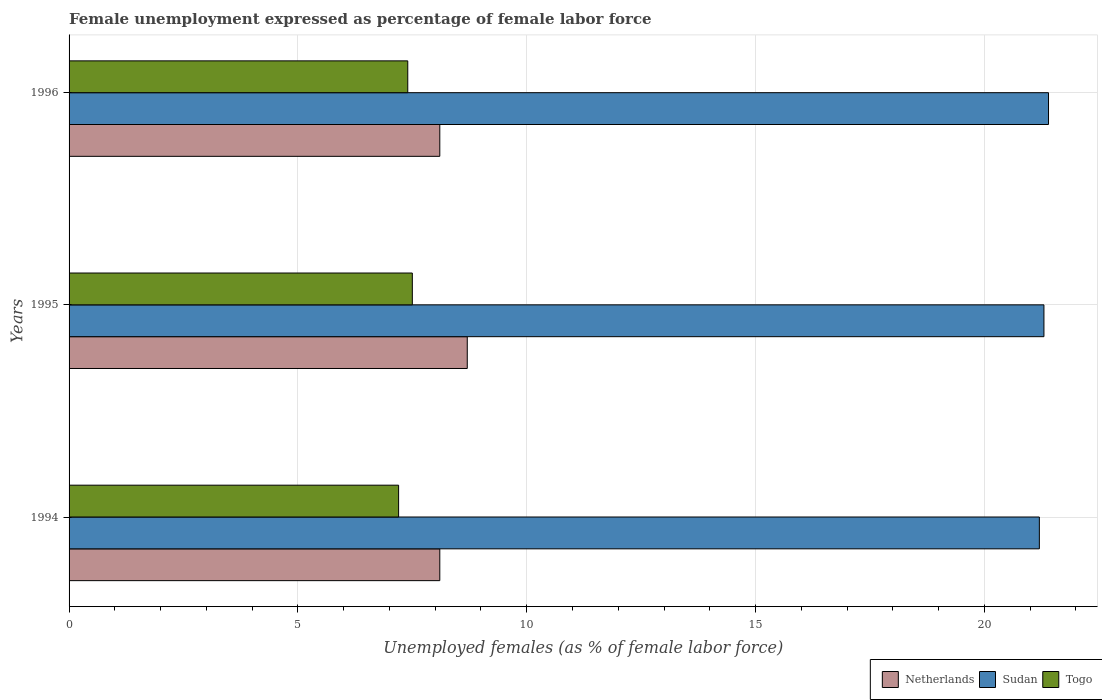How many groups of bars are there?
Your answer should be compact. 3. Are the number of bars per tick equal to the number of legend labels?
Offer a very short reply. Yes. Are the number of bars on each tick of the Y-axis equal?
Make the answer very short. Yes. How many bars are there on the 1st tick from the bottom?
Your answer should be compact. 3. In how many cases, is the number of bars for a given year not equal to the number of legend labels?
Keep it short and to the point. 0. Across all years, what is the maximum unemployment in females in in Netherlands?
Keep it short and to the point. 8.7. Across all years, what is the minimum unemployment in females in in Sudan?
Give a very brief answer. 21.2. In which year was the unemployment in females in in Netherlands maximum?
Provide a short and direct response. 1995. In which year was the unemployment in females in in Sudan minimum?
Ensure brevity in your answer.  1994. What is the total unemployment in females in in Netherlands in the graph?
Provide a short and direct response. 24.9. What is the difference between the unemployment in females in in Togo in 1995 and that in 1996?
Your response must be concise. 0.1. What is the difference between the unemployment in females in in Netherlands in 1994 and the unemployment in females in in Togo in 1996?
Give a very brief answer. 0.7. What is the average unemployment in females in in Netherlands per year?
Make the answer very short. 8.3. In the year 1994, what is the difference between the unemployment in females in in Sudan and unemployment in females in in Togo?
Your answer should be very brief. 14. What is the ratio of the unemployment in females in in Netherlands in 1994 to that in 1995?
Provide a short and direct response. 0.93. Is the unemployment in females in in Togo in 1994 less than that in 1996?
Offer a very short reply. Yes. Is the difference between the unemployment in females in in Sudan in 1995 and 1996 greater than the difference between the unemployment in females in in Togo in 1995 and 1996?
Your response must be concise. No. What is the difference between the highest and the second highest unemployment in females in in Sudan?
Provide a succinct answer. 0.1. What is the difference between the highest and the lowest unemployment in females in in Sudan?
Give a very brief answer. 0.2. In how many years, is the unemployment in females in in Netherlands greater than the average unemployment in females in in Netherlands taken over all years?
Keep it short and to the point. 1. Is the sum of the unemployment in females in in Netherlands in 1995 and 1996 greater than the maximum unemployment in females in in Togo across all years?
Your response must be concise. Yes. What does the 2nd bar from the top in 1996 represents?
Give a very brief answer. Sudan. What does the 2nd bar from the bottom in 1996 represents?
Your answer should be compact. Sudan. Is it the case that in every year, the sum of the unemployment in females in in Netherlands and unemployment in females in in Togo is greater than the unemployment in females in in Sudan?
Make the answer very short. No. How many years are there in the graph?
Offer a terse response. 3. Does the graph contain any zero values?
Your answer should be compact. No. Does the graph contain grids?
Make the answer very short. Yes. Where does the legend appear in the graph?
Give a very brief answer. Bottom right. How many legend labels are there?
Keep it short and to the point. 3. How are the legend labels stacked?
Make the answer very short. Horizontal. What is the title of the graph?
Offer a very short reply. Female unemployment expressed as percentage of female labor force. What is the label or title of the X-axis?
Give a very brief answer. Unemployed females (as % of female labor force). What is the Unemployed females (as % of female labor force) of Netherlands in 1994?
Make the answer very short. 8.1. What is the Unemployed females (as % of female labor force) of Sudan in 1994?
Offer a very short reply. 21.2. What is the Unemployed females (as % of female labor force) in Togo in 1994?
Offer a very short reply. 7.2. What is the Unemployed females (as % of female labor force) of Netherlands in 1995?
Ensure brevity in your answer.  8.7. What is the Unemployed females (as % of female labor force) in Sudan in 1995?
Offer a very short reply. 21.3. What is the Unemployed females (as % of female labor force) of Netherlands in 1996?
Your answer should be compact. 8.1. What is the Unemployed females (as % of female labor force) in Sudan in 1996?
Give a very brief answer. 21.4. What is the Unemployed females (as % of female labor force) of Togo in 1996?
Offer a terse response. 7.4. Across all years, what is the maximum Unemployed females (as % of female labor force) of Netherlands?
Your response must be concise. 8.7. Across all years, what is the maximum Unemployed females (as % of female labor force) in Sudan?
Provide a short and direct response. 21.4. Across all years, what is the maximum Unemployed females (as % of female labor force) in Togo?
Your response must be concise. 7.5. Across all years, what is the minimum Unemployed females (as % of female labor force) of Netherlands?
Give a very brief answer. 8.1. Across all years, what is the minimum Unemployed females (as % of female labor force) of Sudan?
Your answer should be compact. 21.2. Across all years, what is the minimum Unemployed females (as % of female labor force) in Togo?
Your response must be concise. 7.2. What is the total Unemployed females (as % of female labor force) in Netherlands in the graph?
Your answer should be compact. 24.9. What is the total Unemployed females (as % of female labor force) in Sudan in the graph?
Your answer should be very brief. 63.9. What is the total Unemployed females (as % of female labor force) in Togo in the graph?
Your answer should be compact. 22.1. What is the difference between the Unemployed females (as % of female labor force) in Netherlands in 1994 and that in 1995?
Offer a terse response. -0.6. What is the difference between the Unemployed females (as % of female labor force) in Netherlands in 1994 and that in 1996?
Your response must be concise. 0. What is the difference between the Unemployed females (as % of female labor force) of Togo in 1994 and that in 1996?
Keep it short and to the point. -0.2. What is the difference between the Unemployed females (as % of female labor force) in Netherlands in 1994 and the Unemployed females (as % of female labor force) in Sudan in 1995?
Keep it short and to the point. -13.2. What is the difference between the Unemployed females (as % of female labor force) of Netherlands in 1994 and the Unemployed females (as % of female labor force) of Togo in 1995?
Your answer should be very brief. 0.6. What is the difference between the Unemployed females (as % of female labor force) of Netherlands in 1995 and the Unemployed females (as % of female labor force) of Sudan in 1996?
Keep it short and to the point. -12.7. What is the average Unemployed females (as % of female labor force) in Sudan per year?
Give a very brief answer. 21.3. What is the average Unemployed females (as % of female labor force) of Togo per year?
Your answer should be compact. 7.37. In the year 1994, what is the difference between the Unemployed females (as % of female labor force) of Netherlands and Unemployed females (as % of female labor force) of Togo?
Provide a succinct answer. 0.9. In the year 1994, what is the difference between the Unemployed females (as % of female labor force) of Sudan and Unemployed females (as % of female labor force) of Togo?
Offer a very short reply. 14. In the year 1995, what is the difference between the Unemployed females (as % of female labor force) of Netherlands and Unemployed females (as % of female labor force) of Sudan?
Your answer should be very brief. -12.6. In the year 1995, what is the difference between the Unemployed females (as % of female labor force) of Netherlands and Unemployed females (as % of female labor force) of Togo?
Give a very brief answer. 1.2. In the year 1996, what is the difference between the Unemployed females (as % of female labor force) in Netherlands and Unemployed females (as % of female labor force) in Sudan?
Make the answer very short. -13.3. In the year 1996, what is the difference between the Unemployed females (as % of female labor force) of Sudan and Unemployed females (as % of female labor force) of Togo?
Give a very brief answer. 14. What is the ratio of the Unemployed females (as % of female labor force) of Netherlands in 1994 to that in 1995?
Your answer should be very brief. 0.93. What is the ratio of the Unemployed females (as % of female labor force) in Netherlands in 1994 to that in 1996?
Offer a very short reply. 1. What is the ratio of the Unemployed females (as % of female labor force) of Sudan in 1994 to that in 1996?
Provide a short and direct response. 0.99. What is the ratio of the Unemployed females (as % of female labor force) of Togo in 1994 to that in 1996?
Give a very brief answer. 0.97. What is the ratio of the Unemployed females (as % of female labor force) in Netherlands in 1995 to that in 1996?
Offer a very short reply. 1.07. What is the ratio of the Unemployed females (as % of female labor force) of Sudan in 1995 to that in 1996?
Your response must be concise. 1. What is the ratio of the Unemployed females (as % of female labor force) in Togo in 1995 to that in 1996?
Your response must be concise. 1.01. What is the difference between the highest and the second highest Unemployed females (as % of female labor force) in Netherlands?
Offer a very short reply. 0.6. What is the difference between the highest and the second highest Unemployed females (as % of female labor force) of Sudan?
Offer a terse response. 0.1. What is the difference between the highest and the lowest Unemployed females (as % of female labor force) in Netherlands?
Provide a succinct answer. 0.6. What is the difference between the highest and the lowest Unemployed females (as % of female labor force) in Sudan?
Your response must be concise. 0.2. 